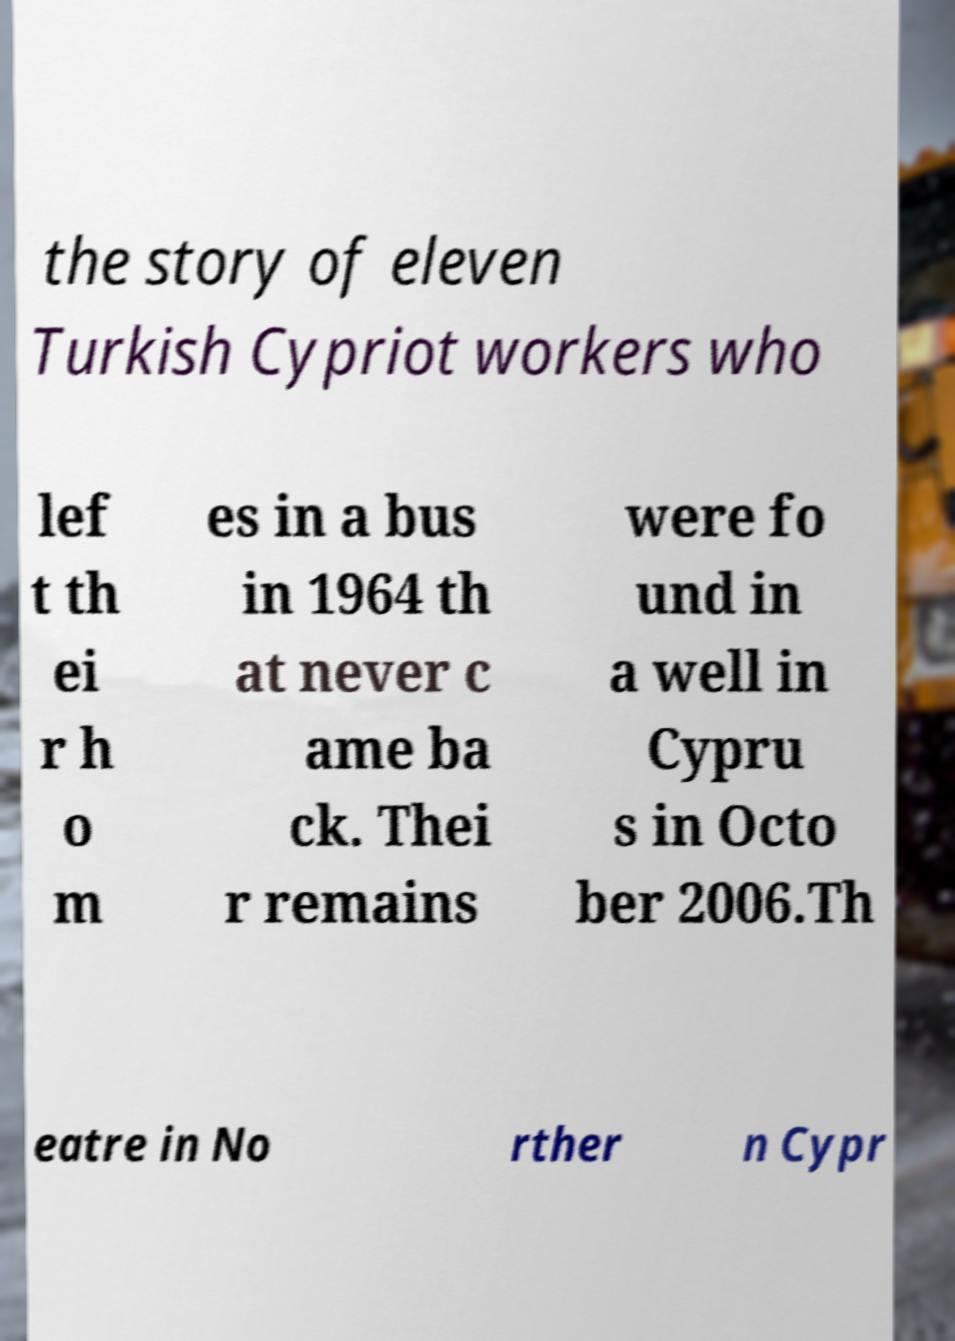Can you accurately transcribe the text from the provided image for me? the story of eleven Turkish Cypriot workers who lef t th ei r h o m es in a bus in 1964 th at never c ame ba ck. Thei r remains were fo und in a well in Cypru s in Octo ber 2006.Th eatre in No rther n Cypr 